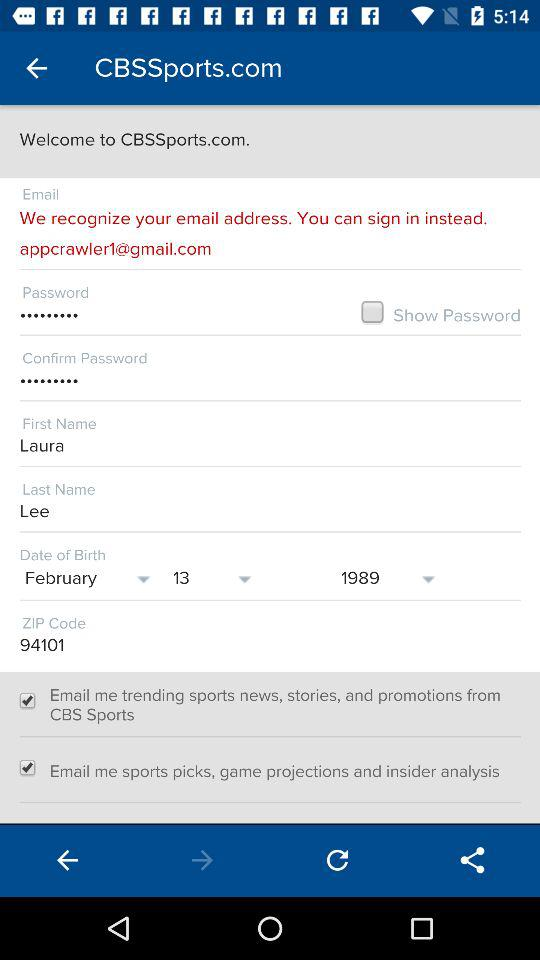What is the ZIP Code? The ZIP Code is 94101. 